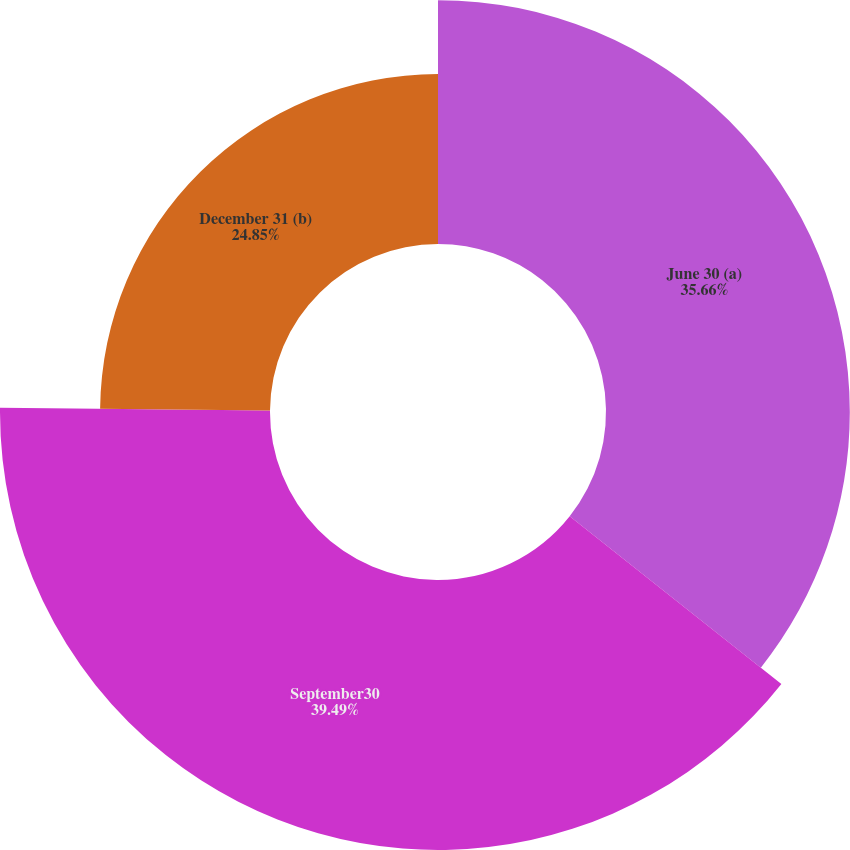Convert chart. <chart><loc_0><loc_0><loc_500><loc_500><pie_chart><fcel>June 30 (a)<fcel>September30<fcel>December 31 (b)<nl><fcel>35.66%<fcel>39.49%<fcel>24.85%<nl></chart> 